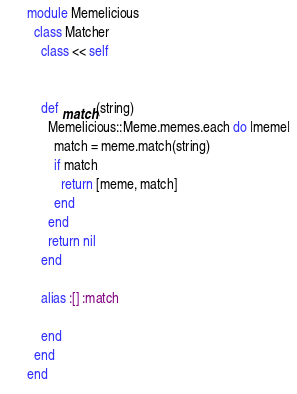<code> <loc_0><loc_0><loc_500><loc_500><_Ruby_>module Memelicious
  class Matcher
    class << self


    def match(string)
      Memelicious::Meme.memes.each do |meme|
        match = meme.match(string)
        if match
          return [meme, match]
        end
      end
      return nil
    end

    alias :[] :match

    end
  end
end
</code> 